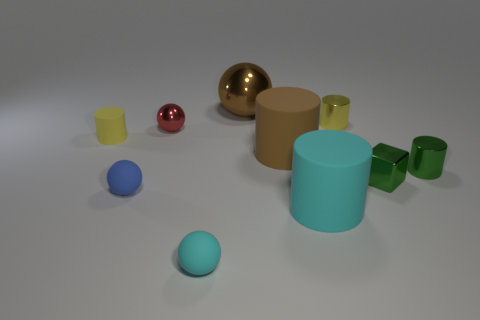Do the small shiny ball and the big metallic ball have the same color?
Offer a terse response. No. How many other objects are the same material as the red thing?
Provide a succinct answer. 4. What shape is the big matte object behind the large matte cylinder in front of the blue ball?
Your answer should be compact. Cylinder. How big is the cyan object that is behind the tiny cyan matte object?
Make the answer very short. Large. Is the small blue sphere made of the same material as the brown cylinder?
Give a very brief answer. Yes. What is the shape of the yellow thing that is made of the same material as the large cyan thing?
Your answer should be very brief. Cylinder. Is there anything else that is the same color as the tiny rubber cylinder?
Offer a terse response. Yes. There is a tiny matte thing to the right of the small blue sphere; what is its color?
Make the answer very short. Cyan. Does the rubber cylinder that is to the left of the big brown ball have the same color as the cube?
Offer a terse response. No. There is a tiny green thing that is the same shape as the large cyan thing; what is its material?
Provide a succinct answer. Metal. 